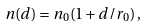Convert formula to latex. <formula><loc_0><loc_0><loc_500><loc_500>n ( d ) = n _ { 0 } ( 1 + d / r _ { 0 } ) \, ,</formula> 